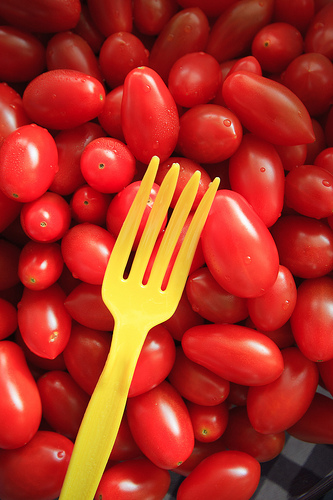<image>
Can you confirm if the yellow fork is on the red tomato? Yes. Looking at the image, I can see the yellow fork is positioned on top of the red tomato, with the red tomato providing support. Is there a tomato to the left of the tomato? Yes. From this viewpoint, the tomato is positioned to the left side relative to the tomato. 